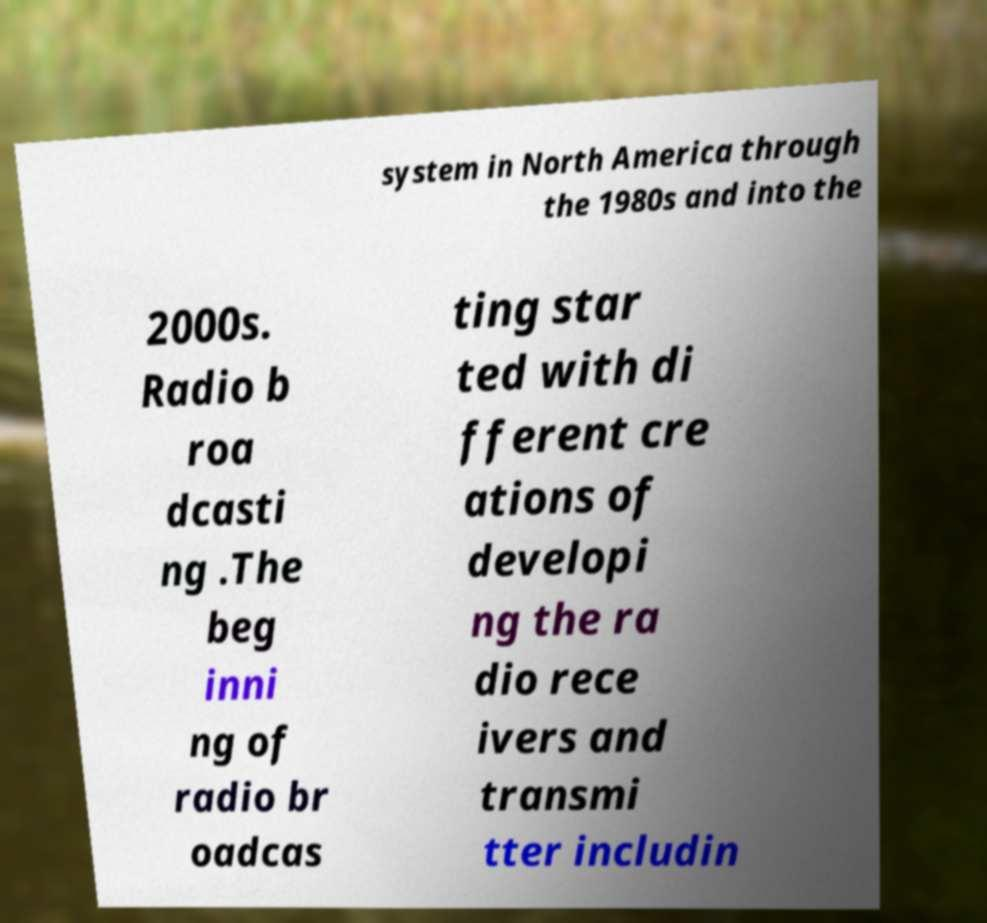Could you assist in decoding the text presented in this image and type it out clearly? system in North America through the 1980s and into the 2000s. Radio b roa dcasti ng .The beg inni ng of radio br oadcas ting star ted with di fferent cre ations of developi ng the ra dio rece ivers and transmi tter includin 